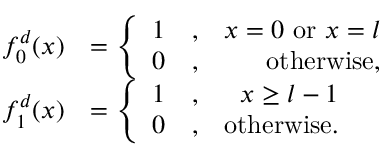Convert formula to latex. <formula><loc_0><loc_0><loc_500><loc_500>\begin{array} { r l } { f _ { 0 } ^ { d } ( x ) } & { = \left \{ \begin{array} { r l r } { 1 } & { , } & { x = 0 o r x = l } \\ { 0 } & { , } & { o t h e r w i s e , } \end{array} } \\ { f _ { 1 } ^ { d } ( x ) } & { = \left \{ \begin{array} { r l r } { 1 } & { , } & { x \geq l - 1 } \\ { 0 } & { , } & { o t h e r w i s e . } \end{array} } \end{array}</formula> 